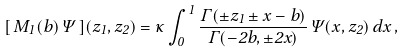Convert formula to latex. <formula><loc_0><loc_0><loc_500><loc_500>[ \, M _ { 1 } ( b ) \, \Psi \, ] ( z _ { 1 } , z _ { 2 } ) = \kappa \int _ { 0 } ^ { 1 } \frac { \Gamma ( \pm z _ { 1 } \pm x - b ) } { \Gamma ( - 2 b , \pm 2 x ) } \, \Psi ( x , z _ { 2 } ) \, d x \, ,</formula> 